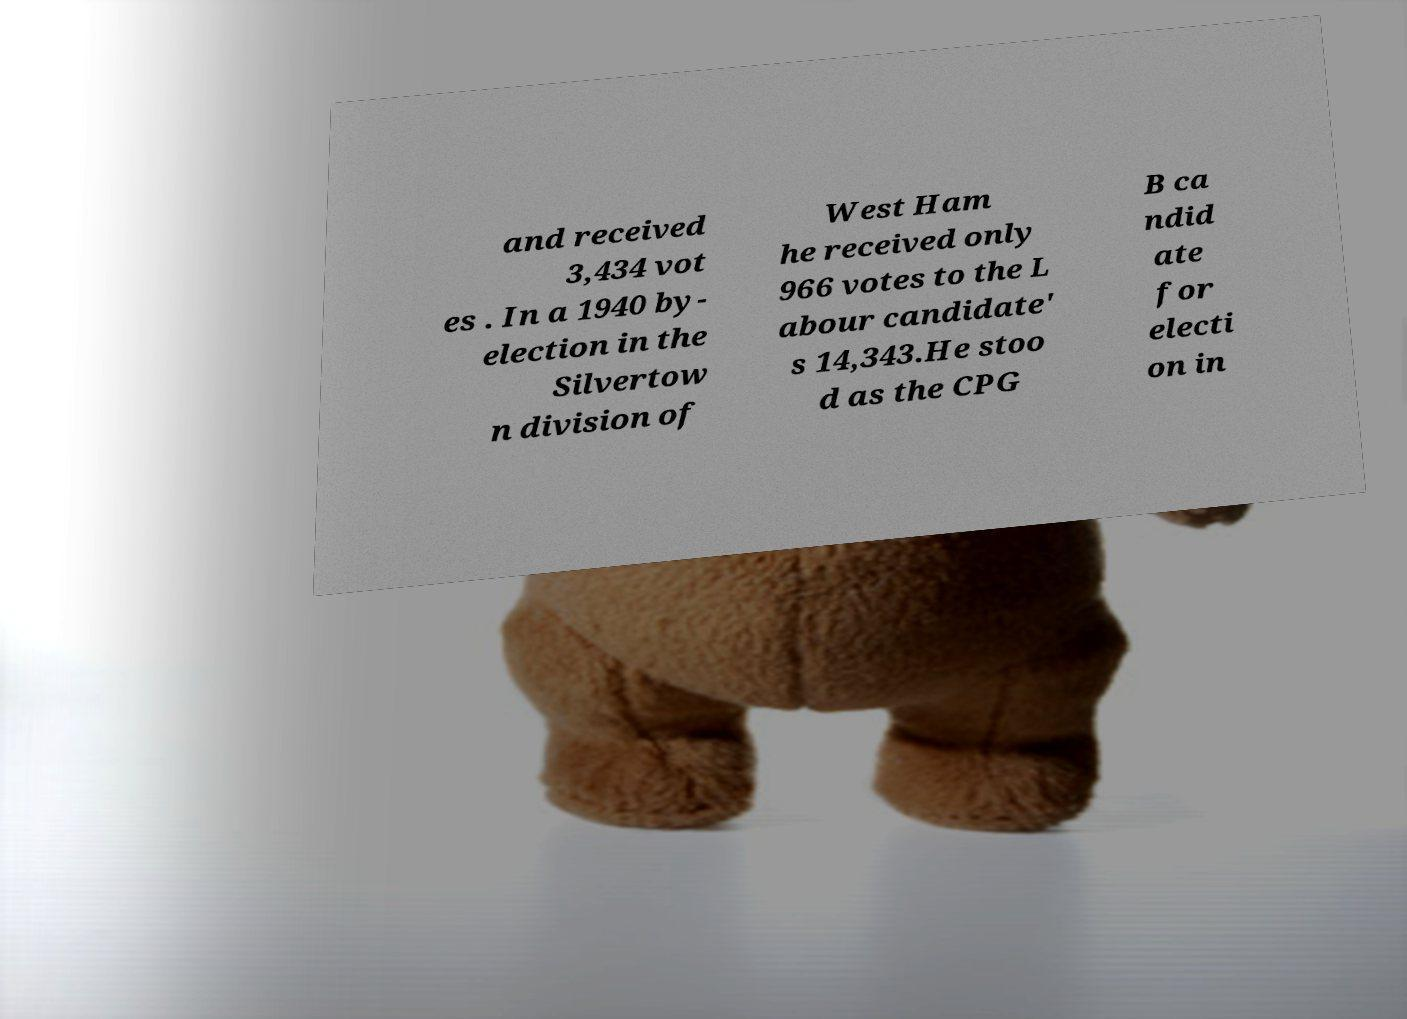Could you assist in decoding the text presented in this image and type it out clearly? and received 3,434 vot es . In a 1940 by- election in the Silvertow n division of West Ham he received only 966 votes to the L abour candidate' s 14,343.He stoo d as the CPG B ca ndid ate for electi on in 